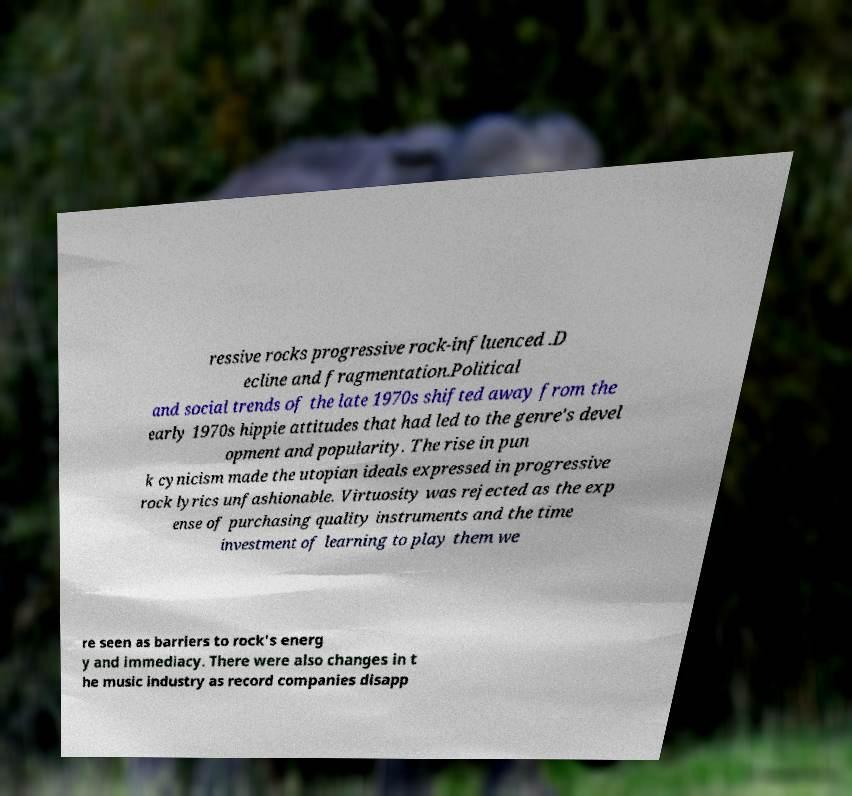Please identify and transcribe the text found in this image. ressive rocks progressive rock-influenced .D ecline and fragmentation.Political and social trends of the late 1970s shifted away from the early 1970s hippie attitudes that had led to the genre's devel opment and popularity. The rise in pun k cynicism made the utopian ideals expressed in progressive rock lyrics unfashionable. Virtuosity was rejected as the exp ense of purchasing quality instruments and the time investment of learning to play them we re seen as barriers to rock's energ y and immediacy. There were also changes in t he music industry as record companies disapp 